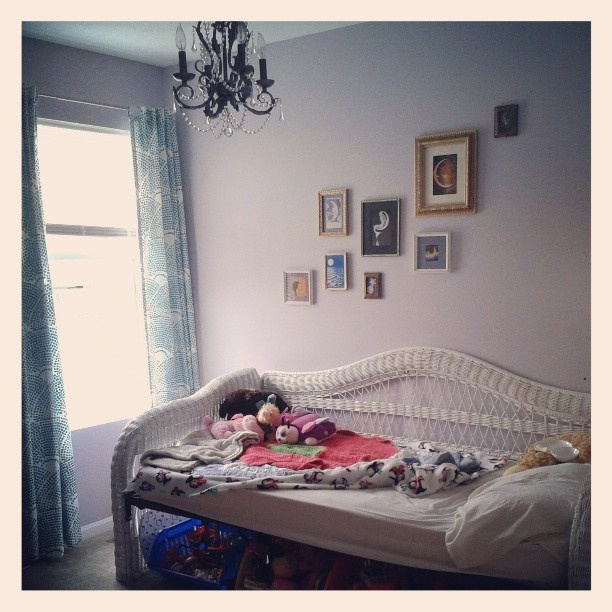Describe the objects in this image and their specific colors. I can see bed in white, gray, darkgray, and black tones, teddy bear in white, purple, brown, and lightpink tones, teddy bear in ivory, black, gray, and darkgray tones, and teddy bear in white, lightpink, brown, darkgray, and gray tones in this image. 